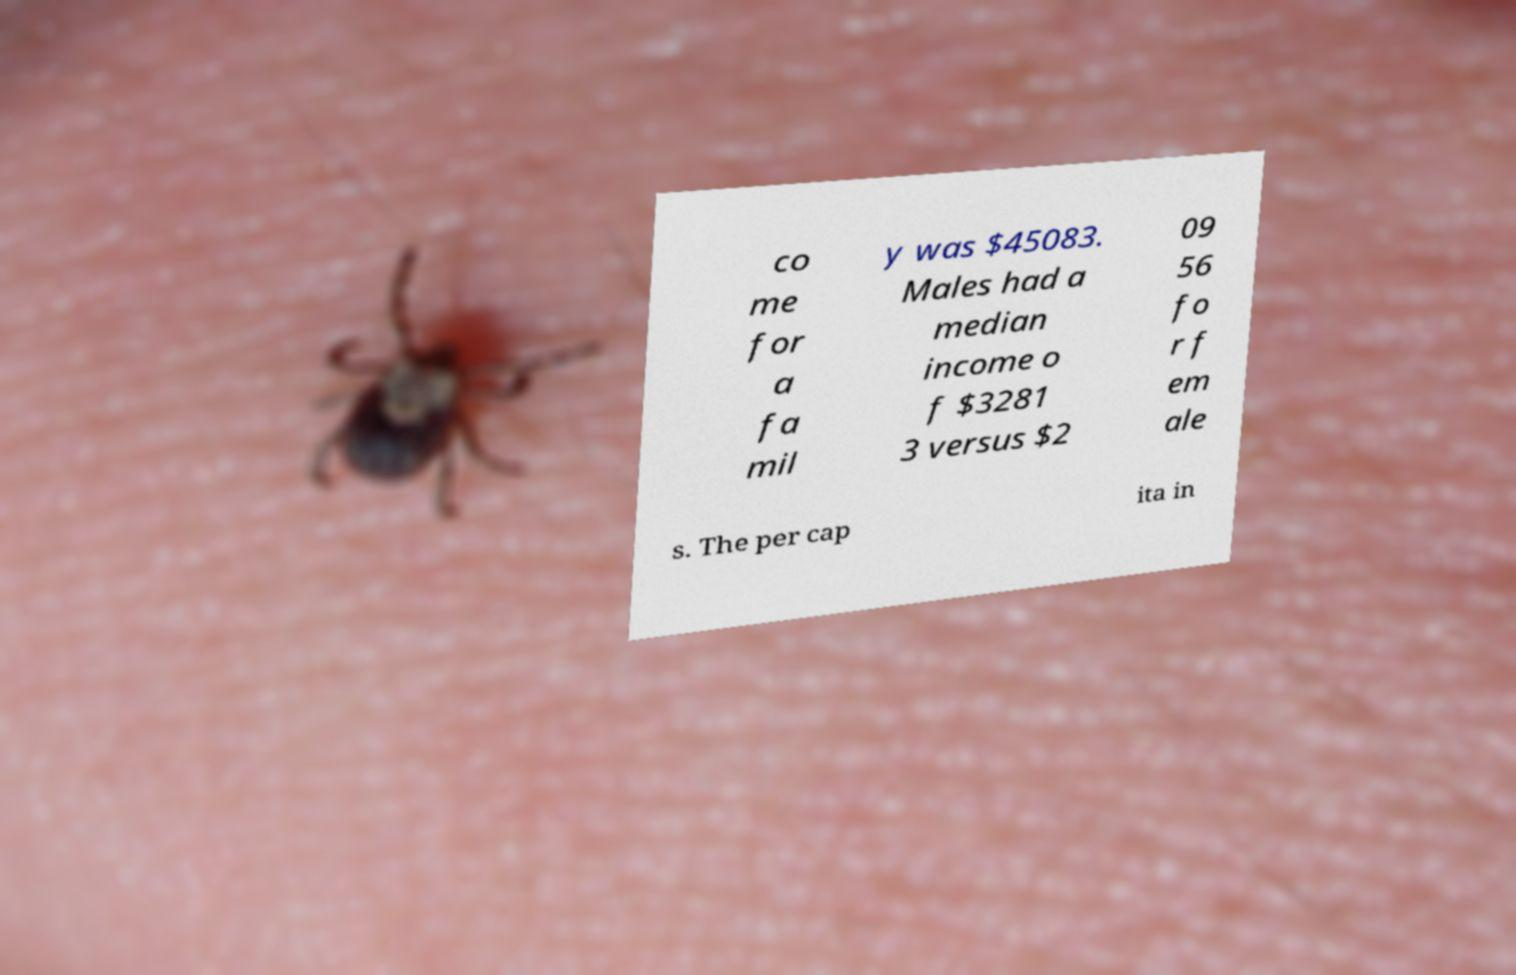Can you accurately transcribe the text from the provided image for me? co me for a fa mil y was $45083. Males had a median income o f $3281 3 versus $2 09 56 fo r f em ale s. The per cap ita in 